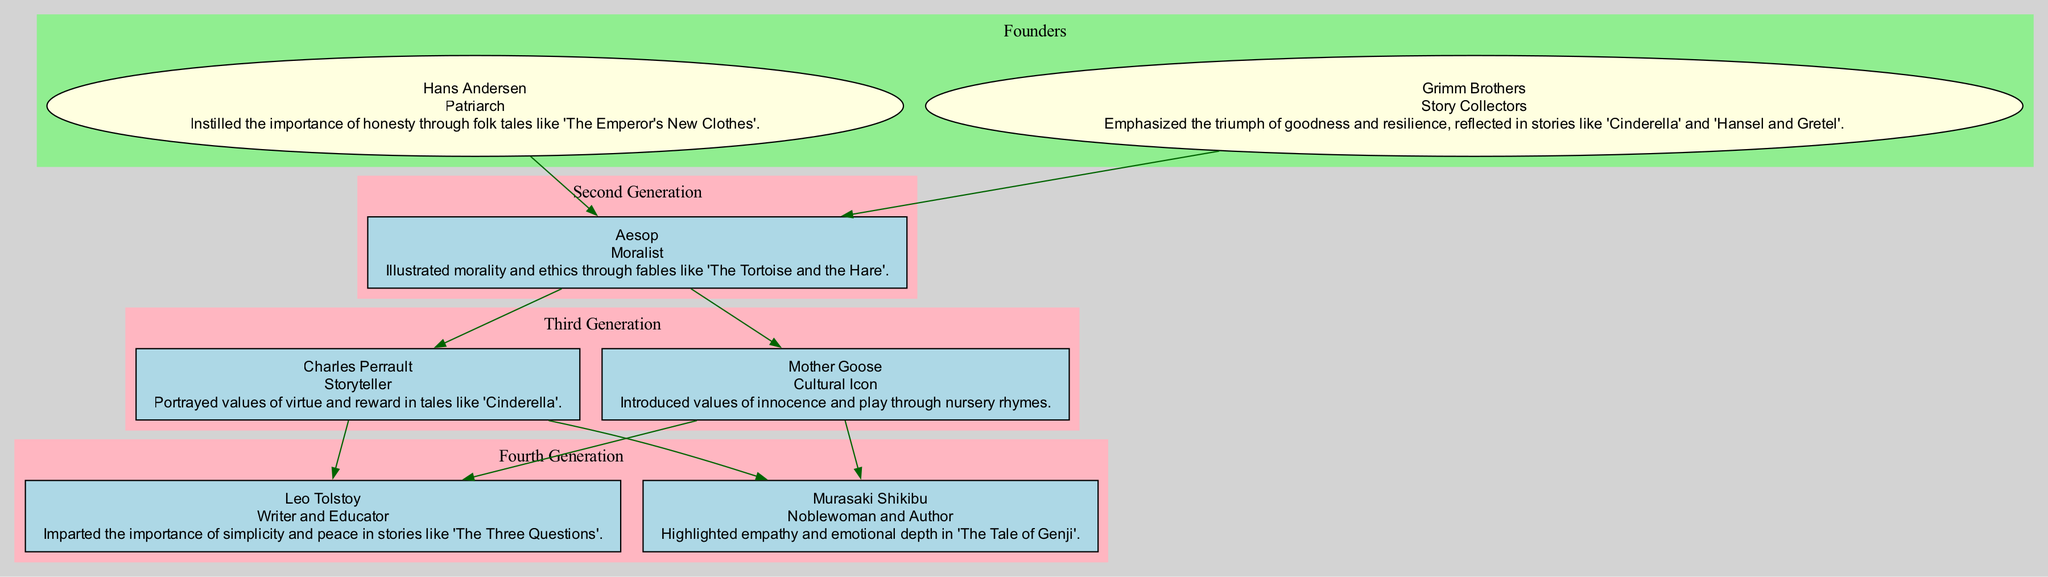What is the role of Hans Andersen? Hans Andersen is listed as the patriarch of the family tree, indicating that he holds a foundational position, contributing significantly to the narrative tradition.
Answer: Patriarch How many generations are represented in the family tree? The family tree includes four generations: Founders, Second Generation, Third Generation, and Fourth Generation. This can be counted based on the different clusters outlined in the diagram.
Answer: 4 Which value did the Grimm Brothers contribute? The value contributed by the Grimm Brothers is associated with the triumph of goodness and resilience, as noted in their tales. This value can be found in the description of their roles.
Answer: Triumph of goodness and resilience Who is the cultural icon in the third generation? Within the third generation, Mother Goose holds the title of cultural icon. This title is explicitly stated in her role description in the diagram.
Answer: Mother Goose What story is associated with Leo Tolstoy? Leo Tolstoy is tied to the story 'The Three Questions', which encapsulates the value contributed by him. This story is listed in the information provided under his contributions.
Answer: The Three Questions What contribution did Murasaki Shikibu make? Murasaki Shikibu highlighted empathy and emotional depth in her work 'The Tale of Genji', which is detailed in her contribution section.
Answer: Empathy and emotional depth Name one value that Aesop illustrated. Aesop illustrated morality and ethics through his fables. This specific contribution is outlined directly under Aesop’s description.
Answer: Morality and ethics Which founder's tale emphasized the importance of honesty? The tale that emphasized the importance of honesty is 'The Emperor's New Clothes', attributed to Hans Andersen, as noted in the value contributed section for the founders.
Answer: The Emperor's New Clothes What connects the second generation to the founders? The connection is made through the edge in the diagram that links Aesop to the founders, indicating a generational transfer of values. It shows that Aesop's moral teachings stem from the foundational tales.
Answer: Aesop 